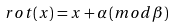Convert formula to latex. <formula><loc_0><loc_0><loc_500><loc_500>\ r o t ( x ) = x + \alpha \, ( m o d \beta )</formula> 